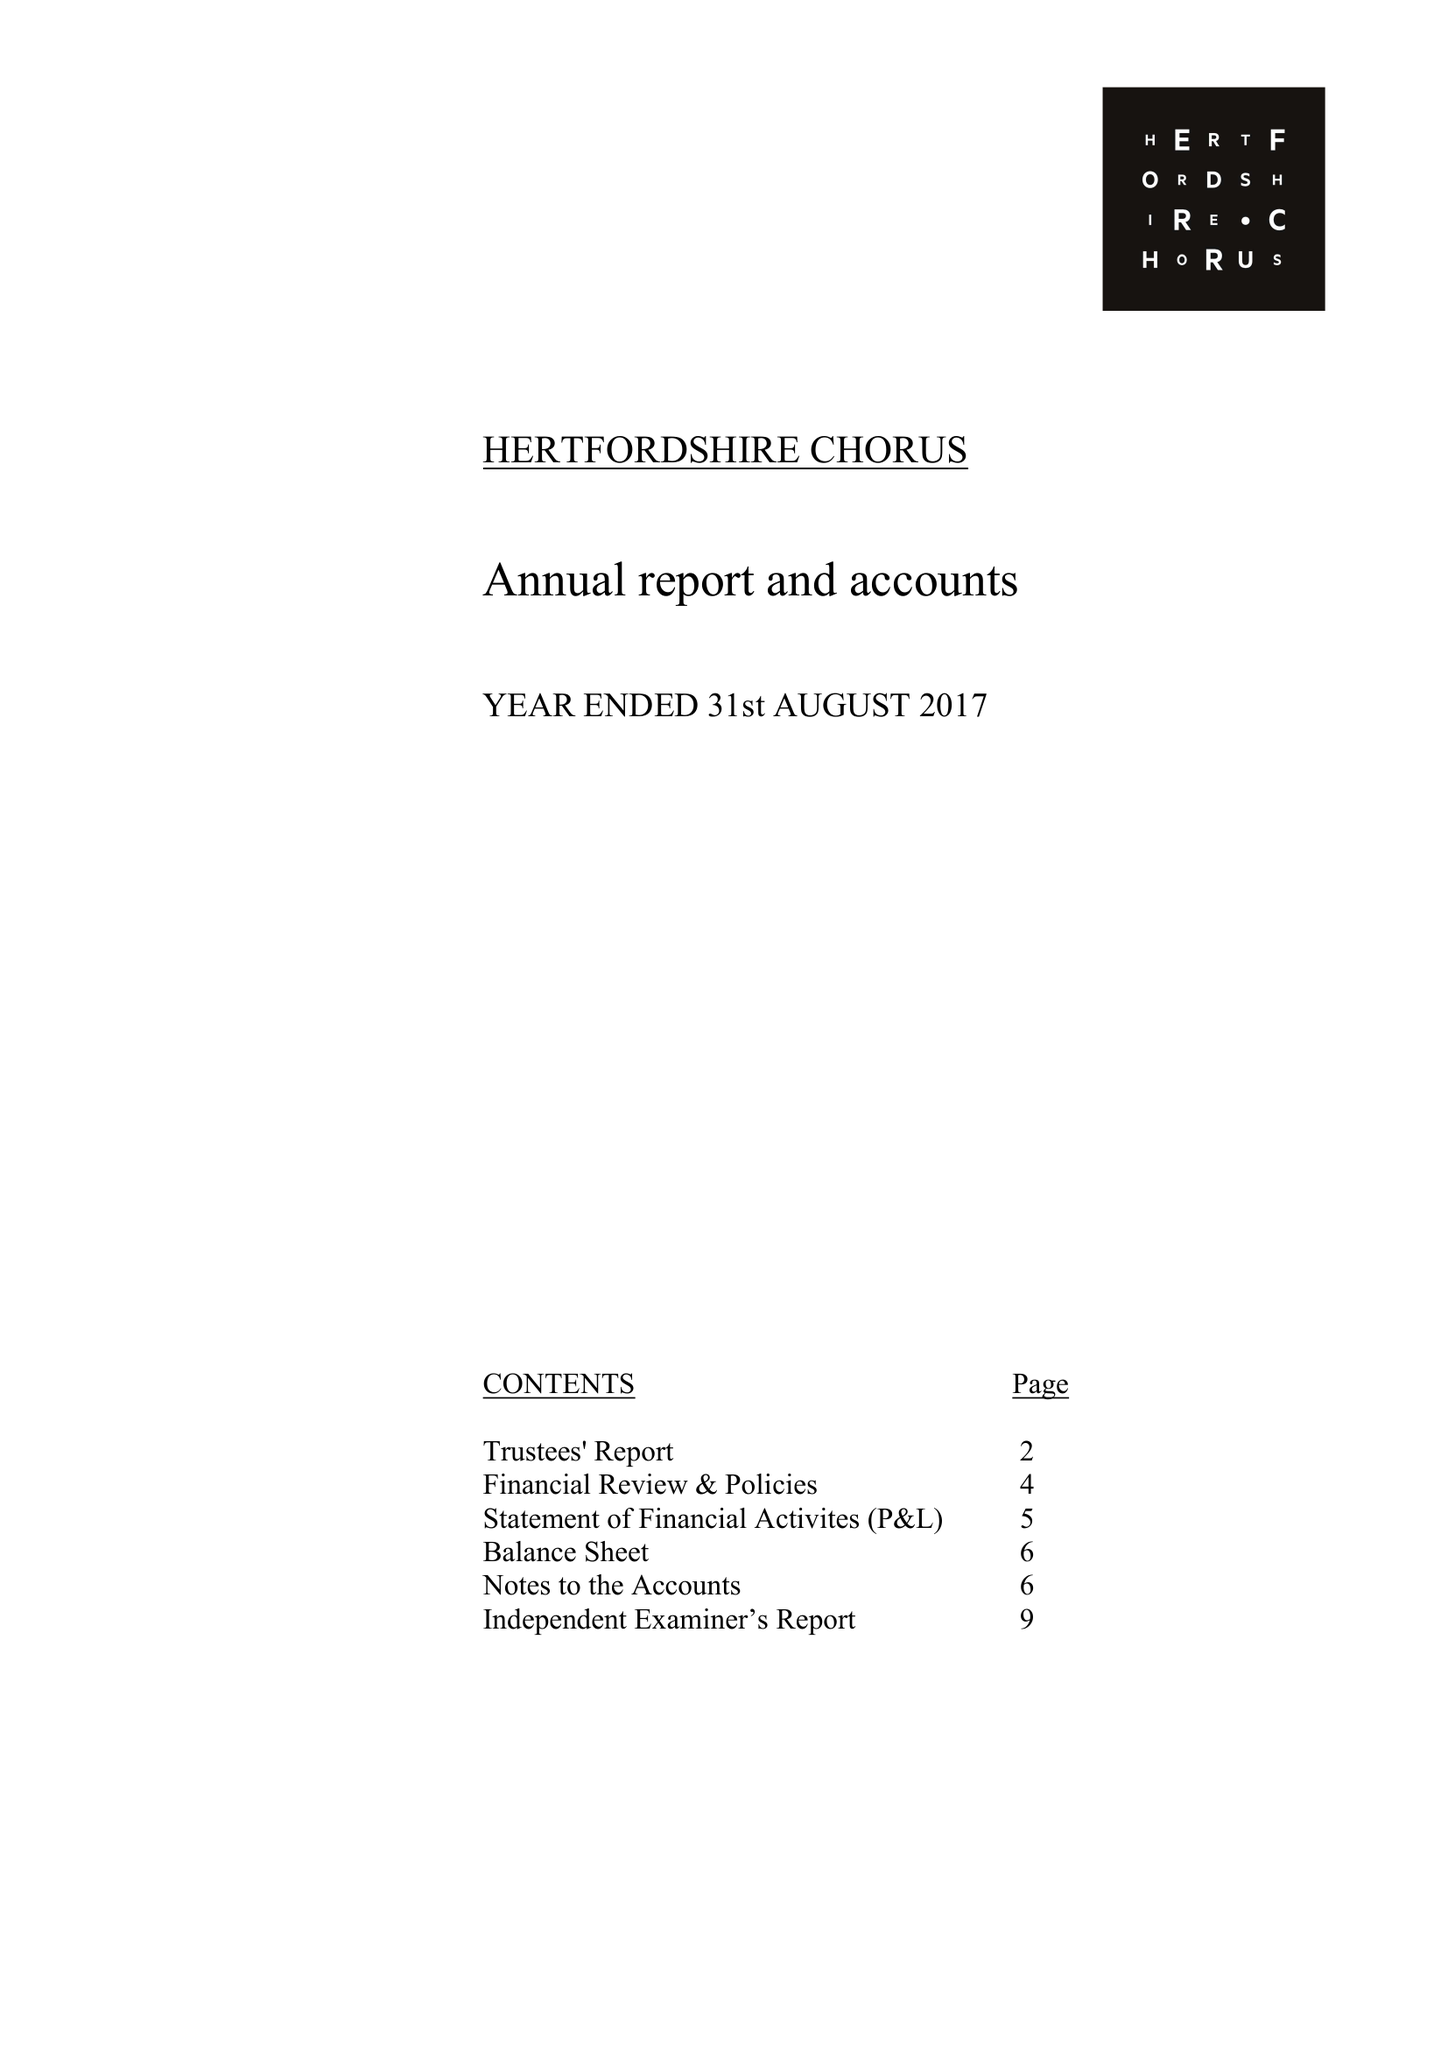What is the value for the income_annually_in_british_pounds?
Answer the question using a single word or phrase. 112715.00 